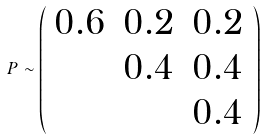<formula> <loc_0><loc_0><loc_500><loc_500>P \sim \left ( \begin{array} { c c c } 0 . 6 & 0 . 2 & 0 . 2 \\ & 0 . 4 & 0 . 4 \\ & & 0 . 4 \end{array} \right )</formula> 